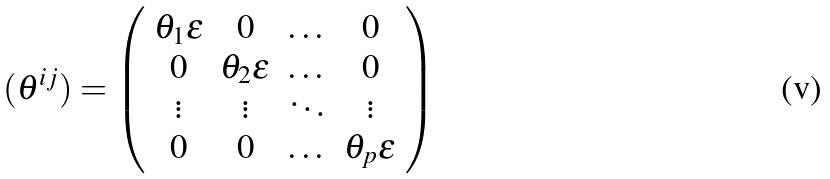<formula> <loc_0><loc_0><loc_500><loc_500>( \theta ^ { i j } ) = \left ( \begin{array} { c c c c } \theta _ { 1 } { \epsilon } & 0 & \dots & 0 \\ 0 & \theta _ { 2 } { \epsilon } & \dots & 0 \\ \vdots & \vdots & \ddots & \vdots \\ 0 & 0 & \dots & \theta _ { p } { \epsilon } \end{array} \right )</formula> 